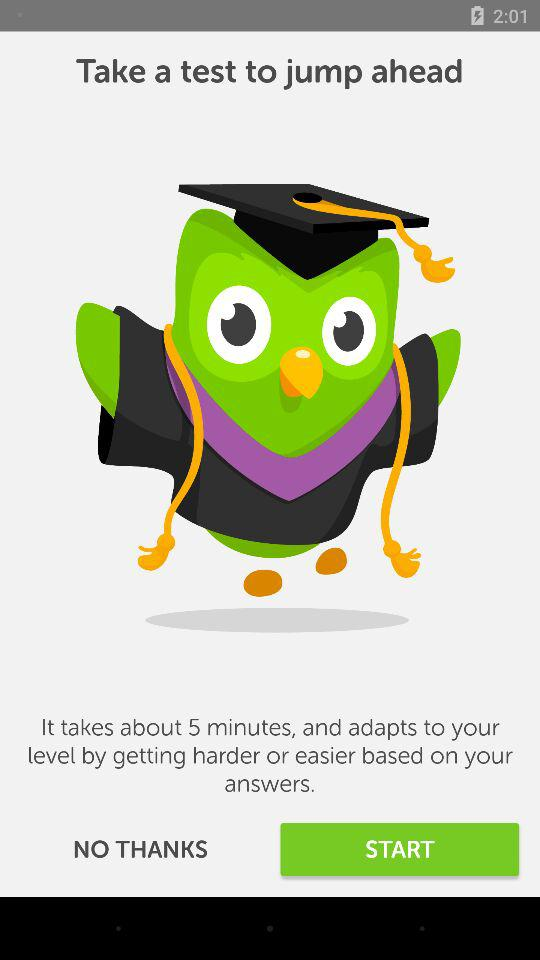How many minutes will the test take? The test will take about 5 minutes. 